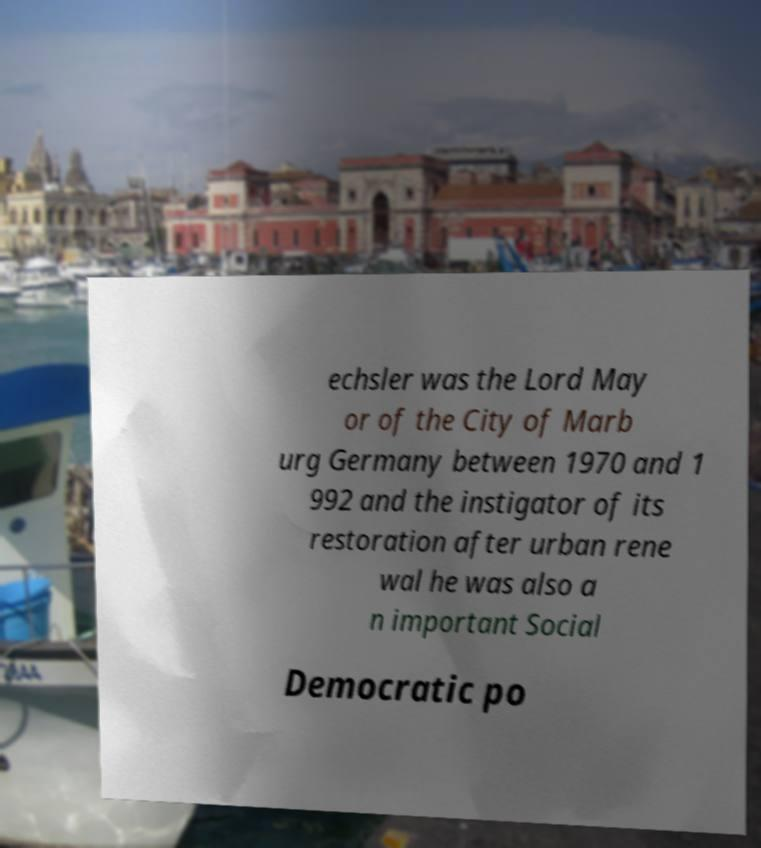Please read and relay the text visible in this image. What does it say? echsler was the Lord May or of the City of Marb urg Germany between 1970 and 1 992 and the instigator of its restoration after urban rene wal he was also a n important Social Democratic po 